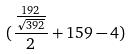<formula> <loc_0><loc_0><loc_500><loc_500>( \frac { \frac { 1 9 2 } { \sqrt { 3 9 2 } } } { 2 } + 1 5 9 - 4 )</formula> 